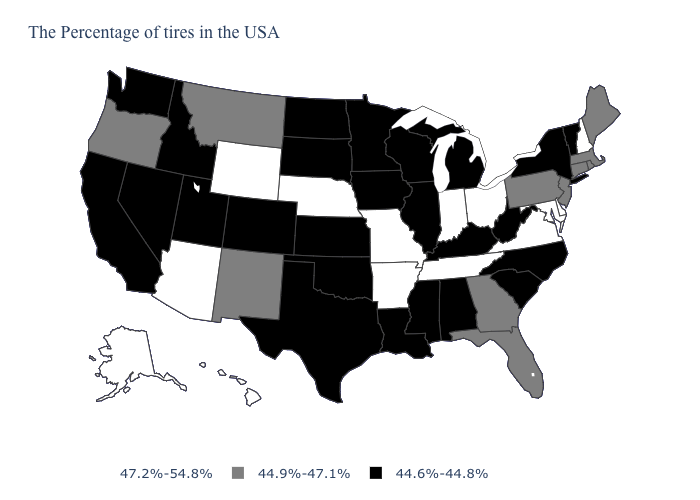What is the value of Minnesota?
Quick response, please. 44.6%-44.8%. What is the value of Maine?
Concise answer only. 44.9%-47.1%. Name the states that have a value in the range 44.6%-44.8%?
Give a very brief answer. Vermont, New York, North Carolina, South Carolina, West Virginia, Michigan, Kentucky, Alabama, Wisconsin, Illinois, Mississippi, Louisiana, Minnesota, Iowa, Kansas, Oklahoma, Texas, South Dakota, North Dakota, Colorado, Utah, Idaho, Nevada, California, Washington. Does Delaware have the same value as South Carolina?
Answer briefly. No. What is the value of Virginia?
Quick response, please. 47.2%-54.8%. What is the highest value in states that border Rhode Island?
Write a very short answer. 44.9%-47.1%. What is the highest value in the South ?
Write a very short answer. 47.2%-54.8%. Name the states that have a value in the range 44.6%-44.8%?
Concise answer only. Vermont, New York, North Carolina, South Carolina, West Virginia, Michigan, Kentucky, Alabama, Wisconsin, Illinois, Mississippi, Louisiana, Minnesota, Iowa, Kansas, Oklahoma, Texas, South Dakota, North Dakota, Colorado, Utah, Idaho, Nevada, California, Washington. Which states hav the highest value in the South?
Quick response, please. Delaware, Maryland, Virginia, Tennessee, Arkansas. Name the states that have a value in the range 47.2%-54.8%?
Be succinct. New Hampshire, Delaware, Maryland, Virginia, Ohio, Indiana, Tennessee, Missouri, Arkansas, Nebraska, Wyoming, Arizona, Alaska, Hawaii. Does Missouri have the lowest value in the MidWest?
Short answer required. No. Name the states that have a value in the range 44.9%-47.1%?
Short answer required. Maine, Massachusetts, Rhode Island, Connecticut, New Jersey, Pennsylvania, Florida, Georgia, New Mexico, Montana, Oregon. What is the lowest value in the West?
Give a very brief answer. 44.6%-44.8%. Name the states that have a value in the range 47.2%-54.8%?
Keep it brief. New Hampshire, Delaware, Maryland, Virginia, Ohio, Indiana, Tennessee, Missouri, Arkansas, Nebraska, Wyoming, Arizona, Alaska, Hawaii. How many symbols are there in the legend?
Give a very brief answer. 3. 